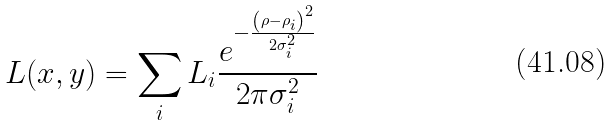<formula> <loc_0><loc_0><loc_500><loc_500>L ( x , y ) = \sum _ { i } L _ { i } \frac { e ^ { - \frac { \left ( { { \rho } - { \rho _ { i } } } \right ) ^ { 2 } } { 2 \sigma _ { i } ^ { 2 } } } } { 2 \pi \sigma _ { i } ^ { 2 } }</formula> 